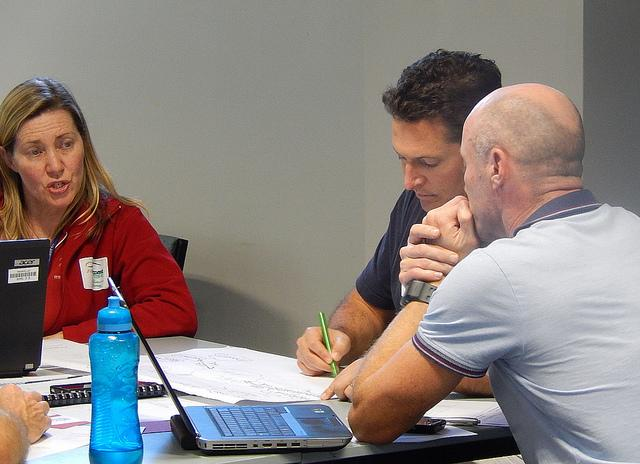The blue bottle is there to satisfy what need? thirst 